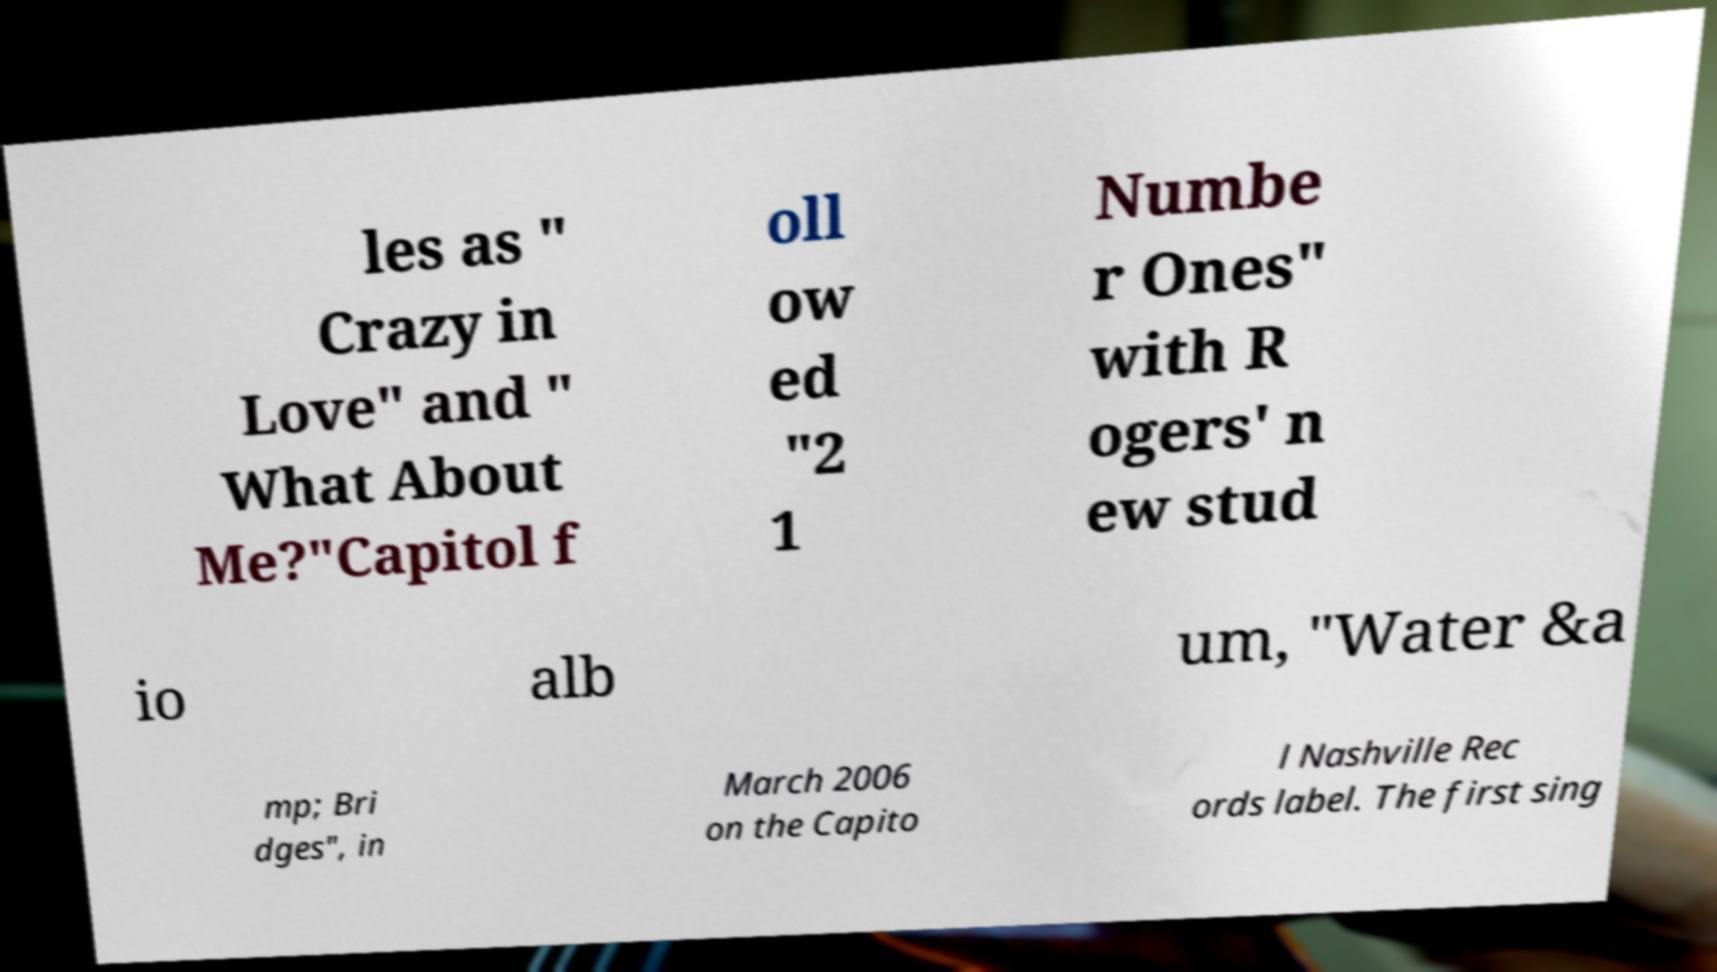Can you read and provide the text displayed in the image?This photo seems to have some interesting text. Can you extract and type it out for me? les as " Crazy in Love" and " What About Me?"Capitol f oll ow ed "2 1 Numbe r Ones" with R ogers' n ew stud io alb um, "Water &a mp; Bri dges", in March 2006 on the Capito l Nashville Rec ords label. The first sing 